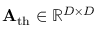<formula> <loc_0><loc_0><loc_500><loc_500>A _ { t h } \in \mathbb { R } ^ { D \times D }</formula> 